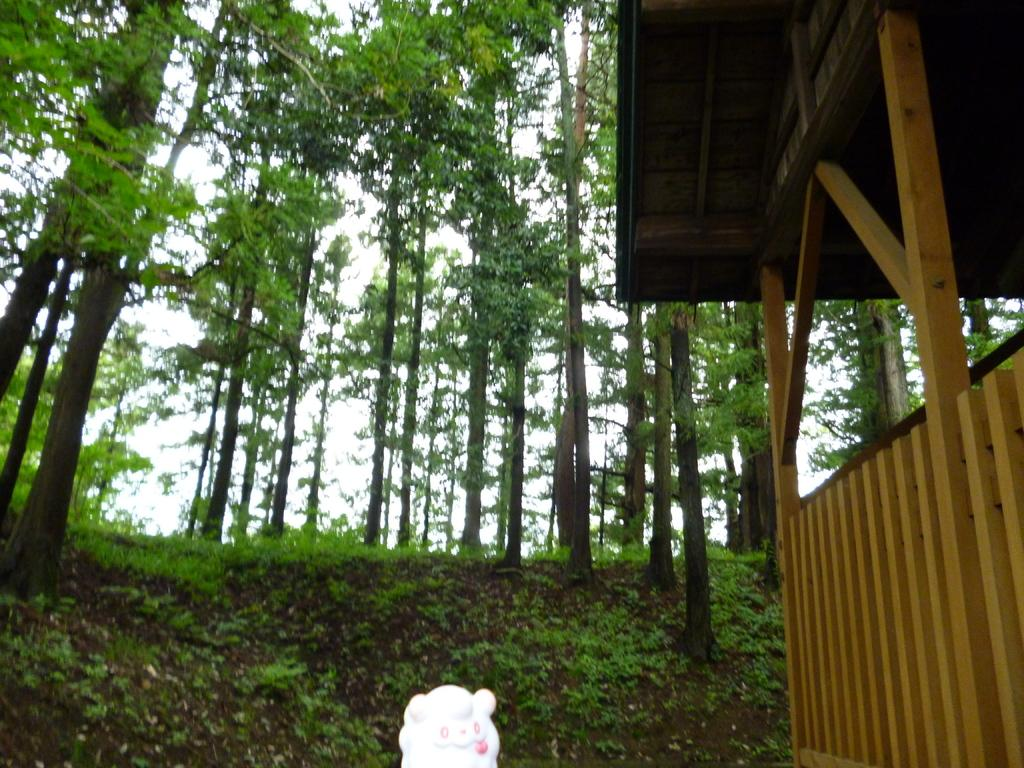What type of vegetation is present in the image? There are trees with branches and leaves in the image. What type of ground cover can be seen in the image? There is grass visible in the image. What type of structure is present in the image? There is a wooden shelter in the image. What type of object is located at the bottom of the image? There is a white toy at the bottom of the image. What type of bomb is being detonated in the image? There is no bomb present in the image; it features trees, grass, a wooden shelter, and a white toy. How does the image depict the act of saying good-bye? The image does not depict the act of saying good-bye; it features trees, grass, a wooden shelter, and a white toy. 